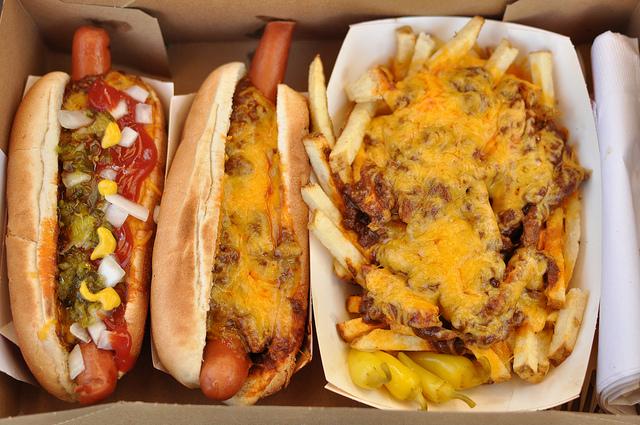Will this be a meal eaten by one person?
Give a very brief answer. No. What is the most spicy food in the box?
Keep it brief. Chili. Is someone not at all concerned about heartburn?
Give a very brief answer. Yes. 